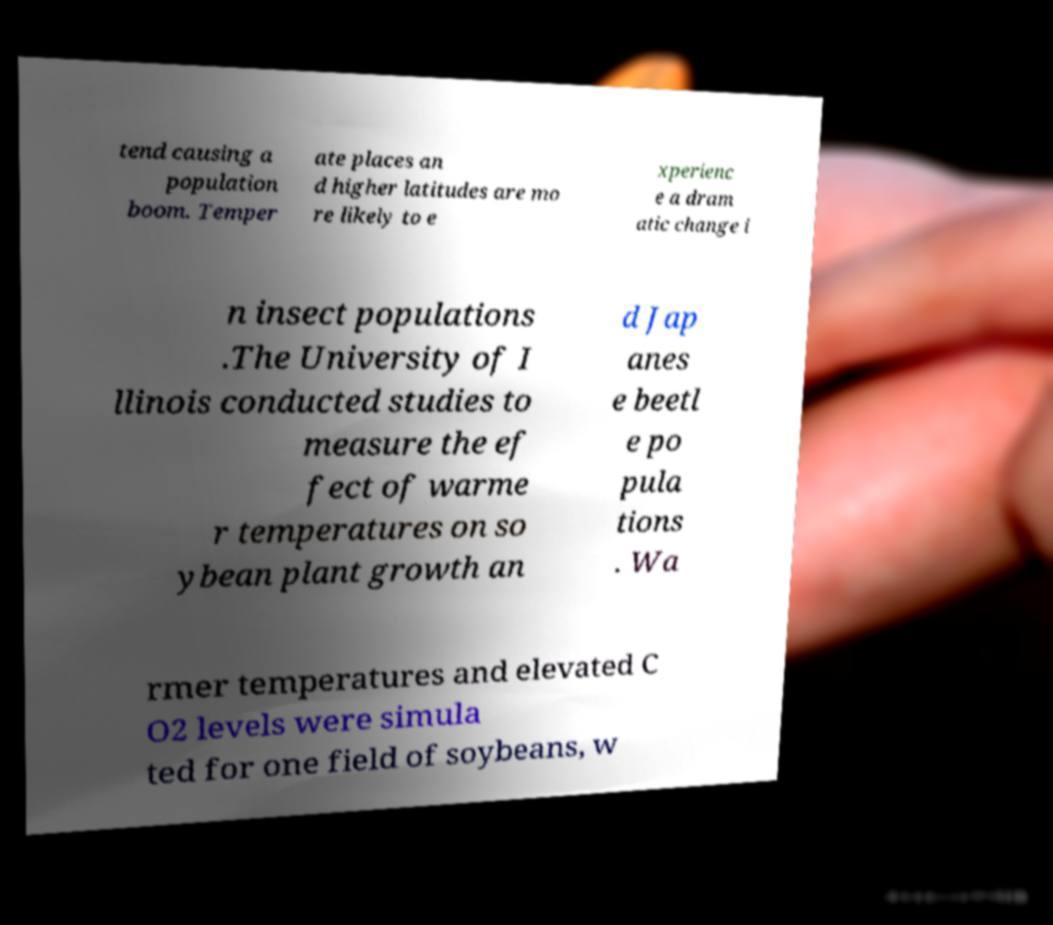Can you read and provide the text displayed in the image?This photo seems to have some interesting text. Can you extract and type it out for me? tend causing a population boom. Temper ate places an d higher latitudes are mo re likely to e xperienc e a dram atic change i n insect populations .The University of I llinois conducted studies to measure the ef fect of warme r temperatures on so ybean plant growth an d Jap anes e beetl e po pula tions . Wa rmer temperatures and elevated C O2 levels were simula ted for one field of soybeans, w 